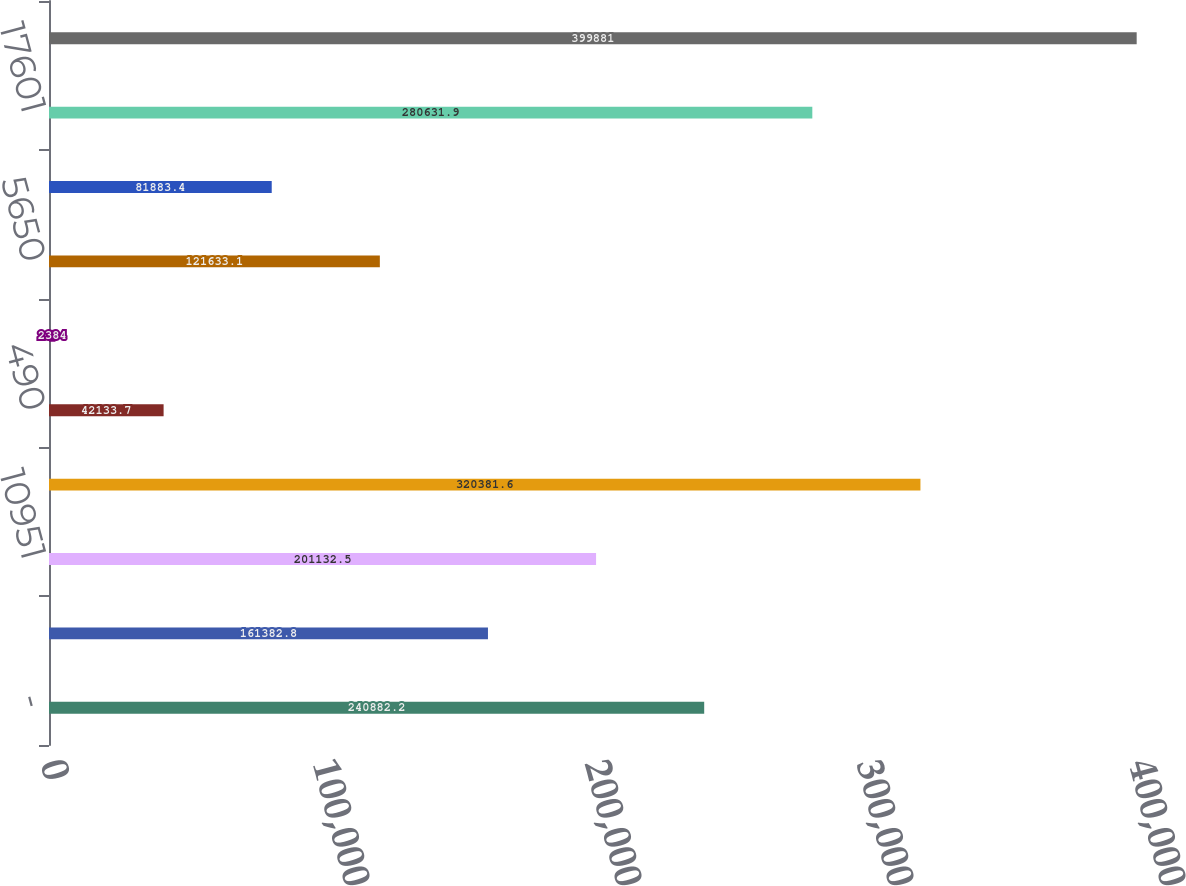Convert chart. <chart><loc_0><loc_0><loc_500><loc_500><bar_chart><fcel>-<fcel>306<fcel>10951<fcel>11257<fcel>490<fcel>1886<fcel>5650<fcel>103<fcel>17601<fcel>36987<nl><fcel>240882<fcel>161383<fcel>201132<fcel>320382<fcel>42133.7<fcel>2384<fcel>121633<fcel>81883.4<fcel>280632<fcel>399881<nl></chart> 